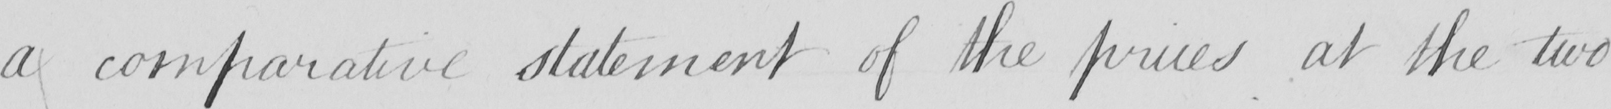Can you read and transcribe this handwriting? a comparative statement of the prices at the two 